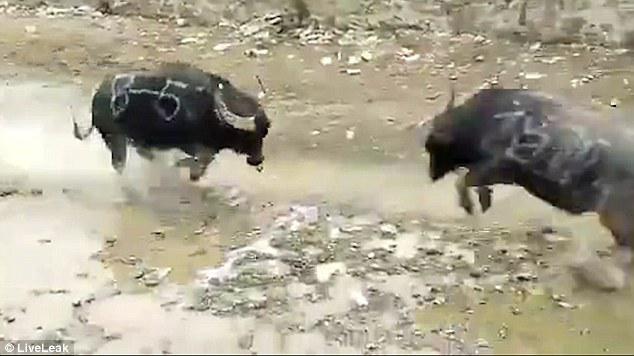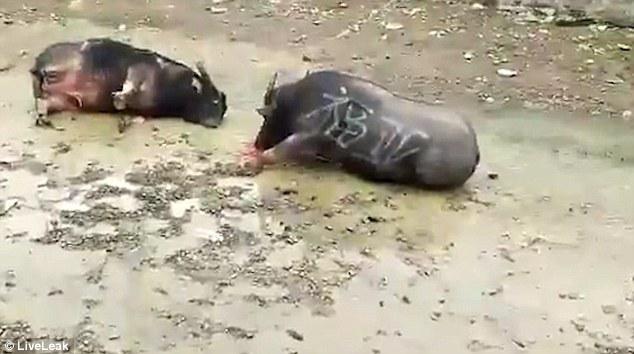The first image is the image on the left, the second image is the image on the right. Assess this claim about the two images: "There are four animals in total in the image pair.". Correct or not? Answer yes or no. Yes. The first image is the image on the left, the second image is the image on the right. Examine the images to the left and right. Is the description "In one of the images the animals are in the wild." accurate? Answer yes or no. No. 